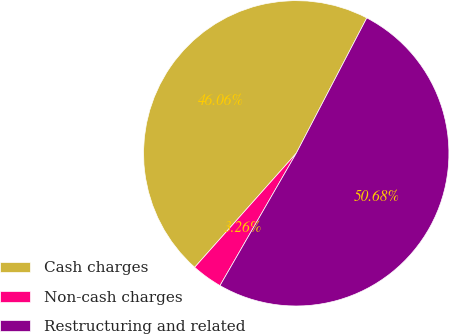Convert chart. <chart><loc_0><loc_0><loc_500><loc_500><pie_chart><fcel>Cash charges<fcel>Non-cash charges<fcel>Restructuring and related<nl><fcel>46.06%<fcel>3.26%<fcel>50.67%<nl></chart> 